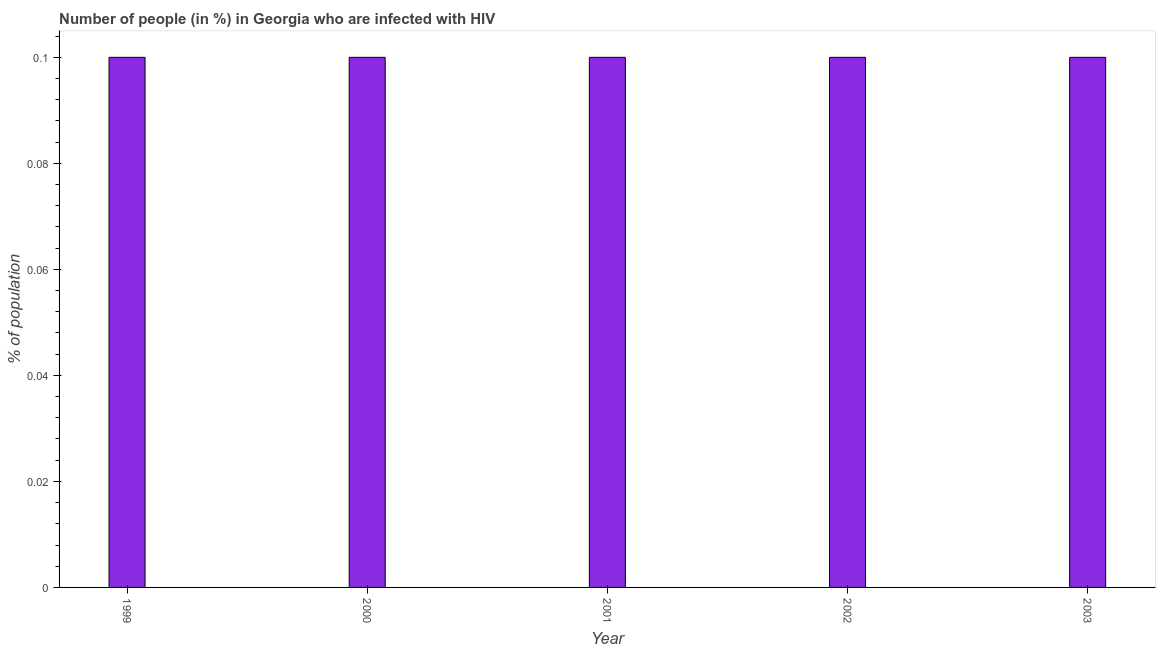Does the graph contain grids?
Your answer should be very brief. No. What is the title of the graph?
Ensure brevity in your answer.  Number of people (in %) in Georgia who are infected with HIV. What is the label or title of the X-axis?
Your response must be concise. Year. What is the label or title of the Y-axis?
Offer a terse response. % of population. What is the number of people infected with hiv in 2003?
Offer a terse response. 0.1. Across all years, what is the maximum number of people infected with hiv?
Your answer should be very brief. 0.1. In which year was the number of people infected with hiv maximum?
Give a very brief answer. 1999. What is the sum of the number of people infected with hiv?
Provide a short and direct response. 0.5. What is the difference between the number of people infected with hiv in 1999 and 2001?
Your response must be concise. 0. What is the average number of people infected with hiv per year?
Make the answer very short. 0.1. Is the number of people infected with hiv in 2002 less than that in 2003?
Make the answer very short. No. Is the difference between the number of people infected with hiv in 2000 and 2003 greater than the difference between any two years?
Your answer should be very brief. Yes. Is the sum of the number of people infected with hiv in 2000 and 2002 greater than the maximum number of people infected with hiv across all years?
Make the answer very short. Yes. What is the difference between the highest and the lowest number of people infected with hiv?
Provide a succinct answer. 0. In how many years, is the number of people infected with hiv greater than the average number of people infected with hiv taken over all years?
Offer a terse response. 0. Are the values on the major ticks of Y-axis written in scientific E-notation?
Your answer should be compact. No. What is the % of population in 2000?
Keep it short and to the point. 0.1. What is the % of population in 2003?
Offer a terse response. 0.1. What is the difference between the % of population in 1999 and 2000?
Offer a very short reply. 0. What is the difference between the % of population in 1999 and 2002?
Provide a succinct answer. 0. What is the difference between the % of population in 2000 and 2001?
Offer a very short reply. 0. What is the difference between the % of population in 2001 and 2002?
Your answer should be compact. 0. What is the difference between the % of population in 2001 and 2003?
Offer a very short reply. 0. What is the difference between the % of population in 2002 and 2003?
Make the answer very short. 0. What is the ratio of the % of population in 1999 to that in 2002?
Keep it short and to the point. 1. What is the ratio of the % of population in 2000 to that in 2002?
Offer a terse response. 1. What is the ratio of the % of population in 2001 to that in 2002?
Make the answer very short. 1. What is the ratio of the % of population in 2001 to that in 2003?
Keep it short and to the point. 1. 